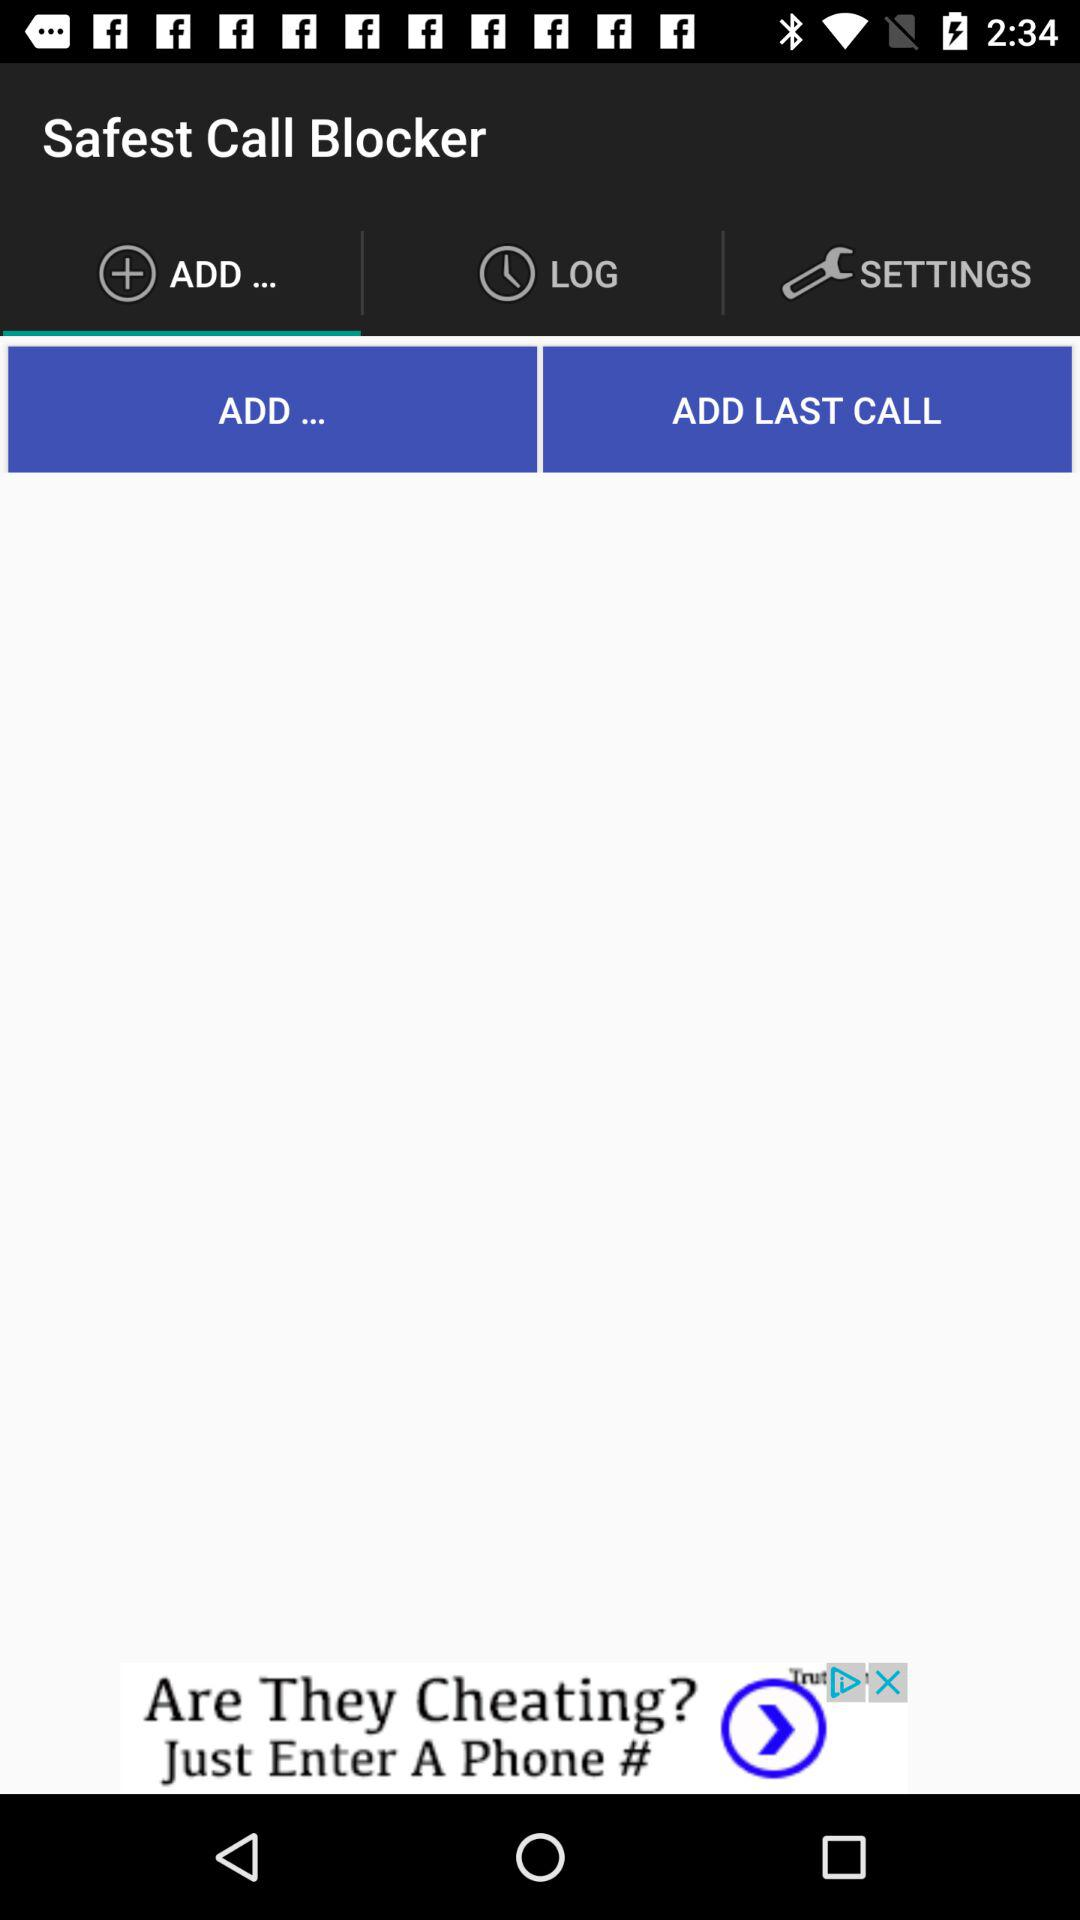What is the selected tab? The selected tab is "ADD...". 